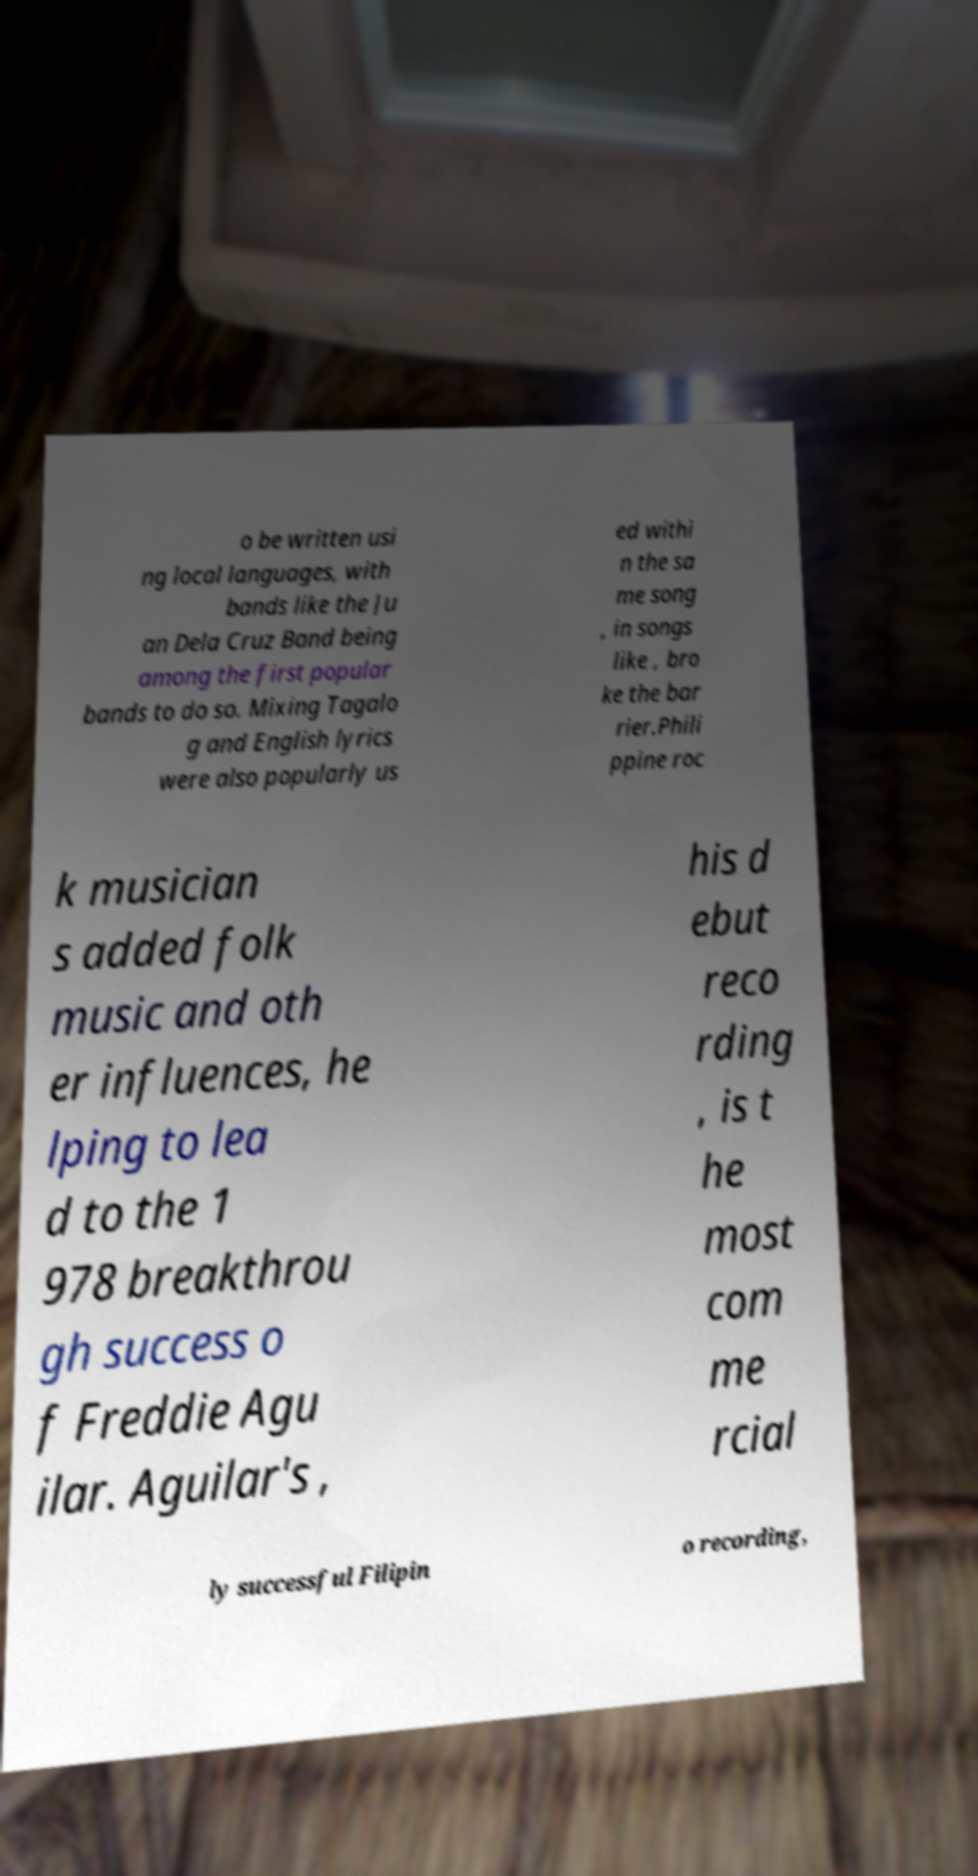What messages or text are displayed in this image? I need them in a readable, typed format. o be written usi ng local languages, with bands like the Ju an Dela Cruz Band being among the first popular bands to do so. Mixing Tagalo g and English lyrics were also popularly us ed withi n the sa me song , in songs like , bro ke the bar rier.Phili ppine roc k musician s added folk music and oth er influences, he lping to lea d to the 1 978 breakthrou gh success o f Freddie Agu ilar. Aguilar's , his d ebut reco rding , is t he most com me rcial ly successful Filipin o recording, 